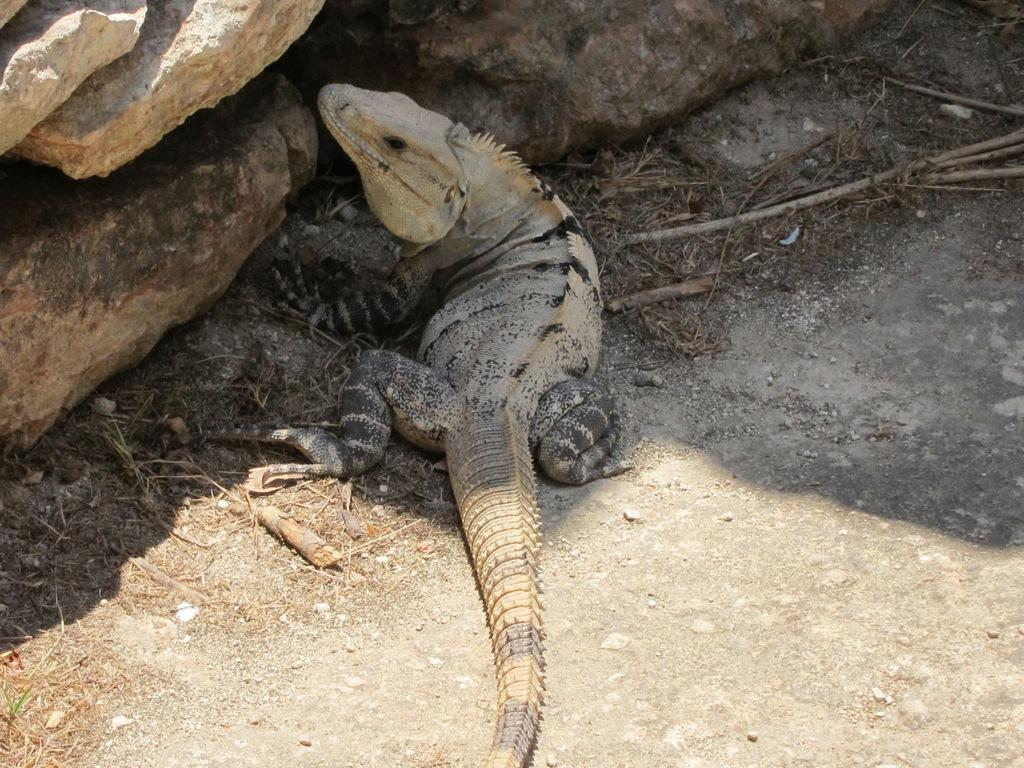What type of animal is present in the image? There is an animal in the image, but its specific type cannot be determined from the provided facts. Can you describe the animal's position in the image? The animal is on the ground in the image. What type of natural element is visible in the image? There is dust visible in the image. What other geological features can be seen in the image? There are rocks in the image. What type of drug is the animal taking in the image? There is no indication in the image that the animal is taking any drug, so it cannot be determined from the picture. How many parent pigs are visible in the image? There is no mention of pigs or parent pigs in the provided facts, so it cannot be determined from the picture. 